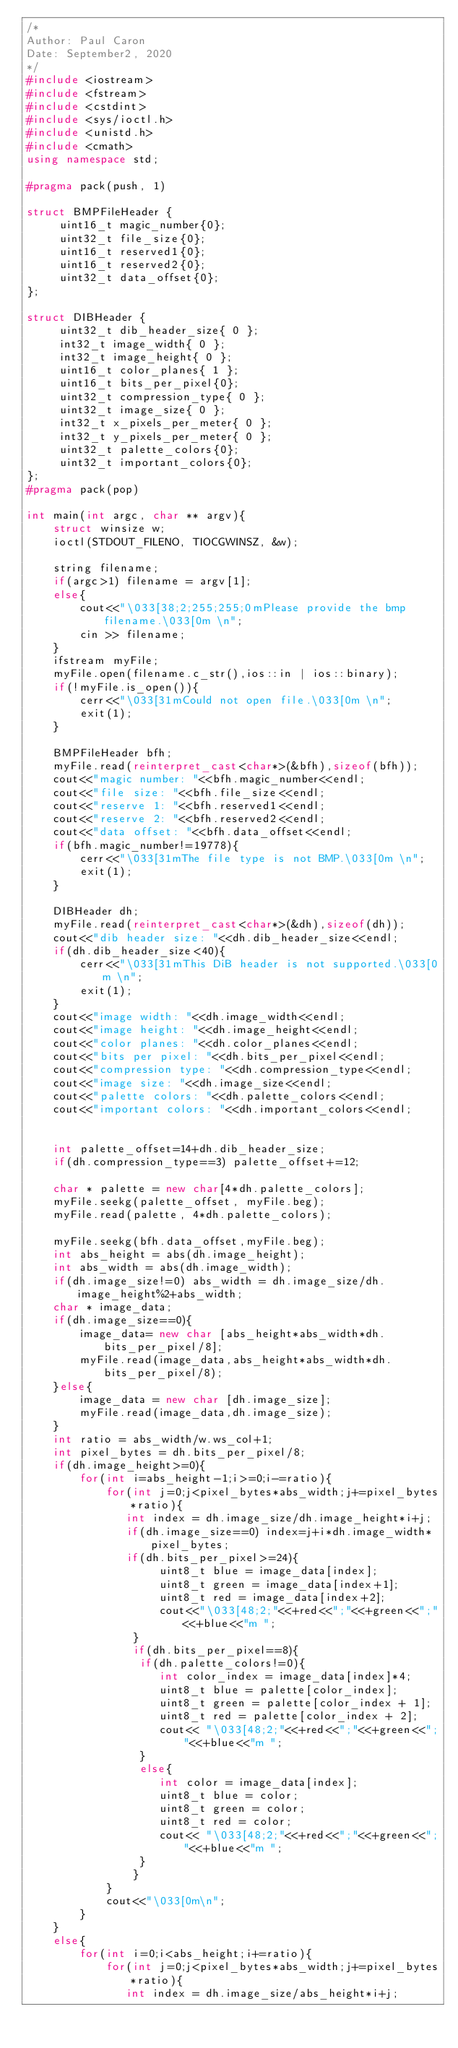Convert code to text. <code><loc_0><loc_0><loc_500><loc_500><_C++_>/*
Author: Paul Caron
Date: September2, 2020
*/
#include <iostream>
#include <fstream>
#include <cstdint>
#include <sys/ioctl.h>
#include <unistd.h>
#include <cmath>
using namespace std;

#pragma pack(push, 1)

struct BMPFileHeader {
     uint16_t magic_number{0};
     uint32_t file_size{0};
     uint16_t reserved1{0};
     uint16_t reserved2{0};
     uint32_t data_offset{0};
};

struct DIBHeader {
     uint32_t dib_header_size{ 0 };
     int32_t image_width{ 0 };
     int32_t image_height{ 0 };
     uint16_t color_planes{ 1 };
     uint16_t bits_per_pixel{0};
     uint32_t compression_type{ 0 };
     uint32_t image_size{ 0 };
     int32_t x_pixels_per_meter{ 0 };
     int32_t y_pixels_per_meter{ 0 };
     uint32_t palette_colors{0};
     uint32_t important_colors{0};
};
#pragma pack(pop)

int main(int argc, char ** argv){
    struct winsize w;
    ioctl(STDOUT_FILENO, TIOCGWINSZ, &w);

    string filename;
    if(argc>1) filename = argv[1];
    else{
        cout<<"\033[38;2;255;255;0mPlease provide the bmp filename.\033[0m \n";
        cin >> filename;
    }
    ifstream myFile;
    myFile.open(filename.c_str(),ios::in | ios::binary);
    if(!myFile.is_open()){
        cerr<<"\033[31mCould not open file.\033[0m \n";
        exit(1);
    }

    BMPFileHeader bfh;
    myFile.read(reinterpret_cast<char*>(&bfh),sizeof(bfh));
    cout<<"magic number: "<<bfh.magic_number<<endl;
    cout<<"file size: "<<bfh.file_size<<endl;
    cout<<"reserve 1: "<<bfh.reserved1<<endl;
    cout<<"reserve 2: "<<bfh.reserved2<<endl;
    cout<<"data offset: "<<bfh.data_offset<<endl;
    if(bfh.magic_number!=19778){
        cerr<<"\033[31mThe file type is not BMP.\033[0m \n";
        exit(1);
    }

    DIBHeader dh;
    myFile.read(reinterpret_cast<char*>(&dh),sizeof(dh));
    cout<<"dib header size: "<<dh.dib_header_size<<endl;
    if(dh.dib_header_size<40){
        cerr<<"\033[31mThis DiB header is not supported.\033[0m \n";
        exit(1);
    }
    cout<<"image width: "<<dh.image_width<<endl;
    cout<<"image height: "<<dh.image_height<<endl;
    cout<<"color planes: "<<dh.color_planes<<endl;
    cout<<"bits per pixel: "<<dh.bits_per_pixel<<endl;
    cout<<"compression type: "<<dh.compression_type<<endl;
    cout<<"image size: "<<dh.image_size<<endl;
    cout<<"palette colors: "<<dh.palette_colors<<endl;
    cout<<"important colors: "<<dh.important_colors<<endl;


    int palette_offset=14+dh.dib_header_size;
    if(dh.compression_type==3) palette_offset+=12;

    char * palette = new char[4*dh.palette_colors];
    myFile.seekg(palette_offset, myFile.beg);
    myFile.read(palette, 4*dh.palette_colors);

    myFile.seekg(bfh.data_offset,myFile.beg);
    int abs_height = abs(dh.image_height);
    int abs_width = abs(dh.image_width);
    if(dh.image_size!=0) abs_width = dh.image_size/dh.image_height%2+abs_width;
    char * image_data;
    if(dh.image_size==0){
        image_data= new char [abs_height*abs_width*dh.bits_per_pixel/8];
        myFile.read(image_data,abs_height*abs_width*dh.bits_per_pixel/8);
    }else{
        image_data = new char [dh.image_size];
        myFile.read(image_data,dh.image_size);
    }
    int ratio = abs_width/w.ws_col+1;
    int pixel_bytes = dh.bits_per_pixel/8;
    if(dh.image_height>=0){
        for(int i=abs_height-1;i>=0;i-=ratio){
            for(int j=0;j<pixel_bytes*abs_width;j+=pixel_bytes*ratio){
               int index = dh.image_size/dh.image_height*i+j;
               if(dh.image_size==0) index=j+i*dh.image_width*pixel_bytes;
               if(dh.bits_per_pixel>=24){
                    uint8_t blue = image_data[index];
                    uint8_t green = image_data[index+1];
                    uint8_t red = image_data[index+2];
                    cout<<"\033[48;2;"<<+red<<";"<<+green<<";"<<+blue<<"m ";
                }
                if(dh.bits_per_pixel==8){
                 if(dh.palette_colors!=0){
                    int color_index = image_data[index]*4;
                    uint8_t blue = palette[color_index];
                    uint8_t green = palette[color_index + 1];
                    uint8_t red = palette[color_index + 2];
                    cout<< "\033[48;2;"<<+red<<";"<<+green<<";"<<+blue<<"m ";
                 }
                 else{
                    int color = image_data[index];
                    uint8_t blue = color;
                    uint8_t green = color;
                    uint8_t red = color;
                    cout<< "\033[48;2;"<<+red<<";"<<+green<<";"<<+blue<<"m ";
                 }
                }
            }
            cout<<"\033[0m\n";
        }
    }
    else{
        for(int i=0;i<abs_height;i+=ratio){
            for(int j=0;j<pixel_bytes*abs_width;j+=pixel_bytes*ratio){
               int index = dh.image_size/abs_height*i+j;</code> 